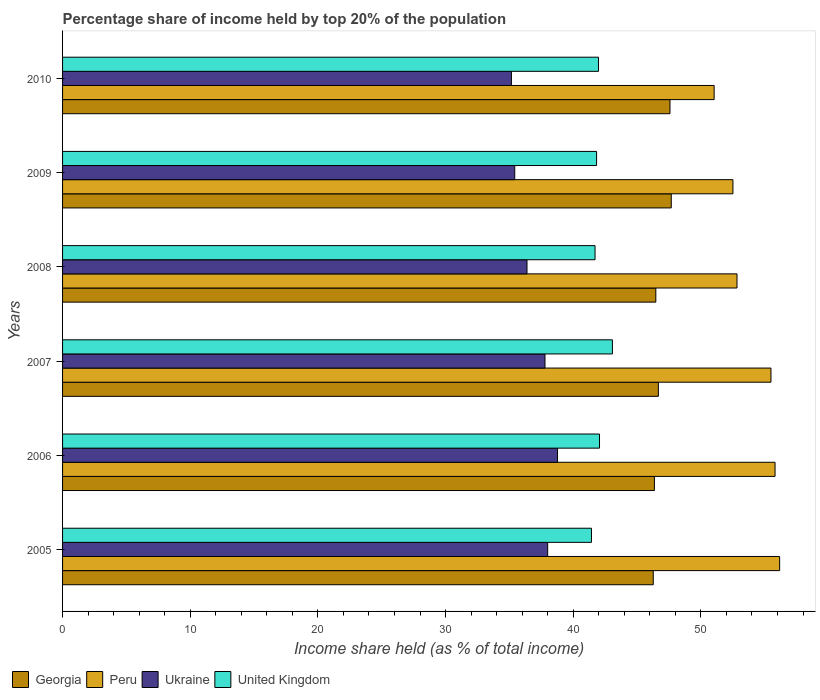How many different coloured bars are there?
Ensure brevity in your answer.  4. How many groups of bars are there?
Keep it short and to the point. 6. Are the number of bars per tick equal to the number of legend labels?
Your answer should be compact. Yes. Are the number of bars on each tick of the Y-axis equal?
Give a very brief answer. Yes. What is the label of the 1st group of bars from the top?
Offer a very short reply. 2010. In how many cases, is the number of bars for a given year not equal to the number of legend labels?
Give a very brief answer. 0. What is the percentage share of income held by top 20% of the population in Ukraine in 2010?
Your answer should be compact. 35.16. Across all years, what is the maximum percentage share of income held by top 20% of the population in Ukraine?
Ensure brevity in your answer.  38.77. Across all years, what is the minimum percentage share of income held by top 20% of the population in Georgia?
Give a very brief answer. 46.27. In which year was the percentage share of income held by top 20% of the population in United Kingdom maximum?
Ensure brevity in your answer.  2007. What is the total percentage share of income held by top 20% of the population in United Kingdom in the graph?
Make the answer very short. 252.08. What is the difference between the percentage share of income held by top 20% of the population in United Kingdom in 2006 and that in 2009?
Give a very brief answer. 0.23. What is the difference between the percentage share of income held by top 20% of the population in Ukraine in 2010 and the percentage share of income held by top 20% of the population in Peru in 2005?
Your answer should be very brief. -21.01. What is the average percentage share of income held by top 20% of the population in Georgia per year?
Provide a succinct answer. 46.84. In the year 2005, what is the difference between the percentage share of income held by top 20% of the population in Peru and percentage share of income held by top 20% of the population in Georgia?
Your answer should be very brief. 9.9. In how many years, is the percentage share of income held by top 20% of the population in Peru greater than 2 %?
Your answer should be compact. 6. What is the ratio of the percentage share of income held by top 20% of the population in Peru in 2007 to that in 2010?
Provide a short and direct response. 1.09. What is the difference between the highest and the second highest percentage share of income held by top 20% of the population in Peru?
Your response must be concise. 0.36. What is the difference between the highest and the lowest percentage share of income held by top 20% of the population in Ukraine?
Keep it short and to the point. 3.61. In how many years, is the percentage share of income held by top 20% of the population in United Kingdom greater than the average percentage share of income held by top 20% of the population in United Kingdom taken over all years?
Ensure brevity in your answer.  2. Is the sum of the percentage share of income held by top 20% of the population in Ukraine in 2006 and 2007 greater than the maximum percentage share of income held by top 20% of the population in Peru across all years?
Your answer should be very brief. Yes. What does the 3rd bar from the bottom in 2008 represents?
Keep it short and to the point. Ukraine. Is it the case that in every year, the sum of the percentage share of income held by top 20% of the population in Ukraine and percentage share of income held by top 20% of the population in Peru is greater than the percentage share of income held by top 20% of the population in United Kingdom?
Offer a terse response. Yes. How many years are there in the graph?
Provide a short and direct response. 6. Does the graph contain grids?
Your answer should be compact. No. Where does the legend appear in the graph?
Your answer should be very brief. Bottom left. How many legend labels are there?
Provide a short and direct response. 4. What is the title of the graph?
Your response must be concise. Percentage share of income held by top 20% of the population. What is the label or title of the X-axis?
Offer a terse response. Income share held (as % of total income). What is the label or title of the Y-axis?
Give a very brief answer. Years. What is the Income share held (as % of total income) in Georgia in 2005?
Keep it short and to the point. 46.27. What is the Income share held (as % of total income) in Peru in 2005?
Provide a succinct answer. 56.17. What is the Income share held (as % of total income) of Ukraine in 2005?
Offer a terse response. 38. What is the Income share held (as % of total income) of United Kingdom in 2005?
Your answer should be compact. 41.43. What is the Income share held (as % of total income) of Georgia in 2006?
Your response must be concise. 46.36. What is the Income share held (as % of total income) of Peru in 2006?
Provide a short and direct response. 55.81. What is the Income share held (as % of total income) in Ukraine in 2006?
Offer a terse response. 38.77. What is the Income share held (as % of total income) of United Kingdom in 2006?
Provide a short and direct response. 42.06. What is the Income share held (as % of total income) in Georgia in 2007?
Your response must be concise. 46.67. What is the Income share held (as % of total income) in Peru in 2007?
Give a very brief answer. 55.49. What is the Income share held (as % of total income) of Ukraine in 2007?
Your answer should be very brief. 37.79. What is the Income share held (as % of total income) in United Kingdom in 2007?
Provide a succinct answer. 43.07. What is the Income share held (as % of total income) in Georgia in 2008?
Make the answer very short. 46.47. What is the Income share held (as % of total income) in Peru in 2008?
Your answer should be very brief. 52.83. What is the Income share held (as % of total income) of Ukraine in 2008?
Your response must be concise. 36.38. What is the Income share held (as % of total income) of United Kingdom in 2008?
Offer a terse response. 41.71. What is the Income share held (as % of total income) in Georgia in 2009?
Offer a terse response. 47.68. What is the Income share held (as % of total income) of Peru in 2009?
Offer a terse response. 52.51. What is the Income share held (as % of total income) in Ukraine in 2009?
Keep it short and to the point. 35.42. What is the Income share held (as % of total income) of United Kingdom in 2009?
Your answer should be compact. 41.83. What is the Income share held (as % of total income) of Georgia in 2010?
Provide a succinct answer. 47.58. What is the Income share held (as % of total income) of Peru in 2010?
Your answer should be very brief. 51.04. What is the Income share held (as % of total income) of Ukraine in 2010?
Your answer should be very brief. 35.16. What is the Income share held (as % of total income) of United Kingdom in 2010?
Your response must be concise. 41.98. Across all years, what is the maximum Income share held (as % of total income) in Georgia?
Keep it short and to the point. 47.68. Across all years, what is the maximum Income share held (as % of total income) in Peru?
Keep it short and to the point. 56.17. Across all years, what is the maximum Income share held (as % of total income) of Ukraine?
Your answer should be compact. 38.77. Across all years, what is the maximum Income share held (as % of total income) of United Kingdom?
Make the answer very short. 43.07. Across all years, what is the minimum Income share held (as % of total income) in Georgia?
Your answer should be very brief. 46.27. Across all years, what is the minimum Income share held (as % of total income) in Peru?
Your answer should be very brief. 51.04. Across all years, what is the minimum Income share held (as % of total income) in Ukraine?
Give a very brief answer. 35.16. Across all years, what is the minimum Income share held (as % of total income) of United Kingdom?
Offer a very short reply. 41.43. What is the total Income share held (as % of total income) in Georgia in the graph?
Your answer should be very brief. 281.03. What is the total Income share held (as % of total income) in Peru in the graph?
Ensure brevity in your answer.  323.85. What is the total Income share held (as % of total income) in Ukraine in the graph?
Give a very brief answer. 221.52. What is the total Income share held (as % of total income) in United Kingdom in the graph?
Provide a short and direct response. 252.08. What is the difference between the Income share held (as % of total income) of Georgia in 2005 and that in 2006?
Offer a terse response. -0.09. What is the difference between the Income share held (as % of total income) in Peru in 2005 and that in 2006?
Offer a terse response. 0.36. What is the difference between the Income share held (as % of total income) in Ukraine in 2005 and that in 2006?
Offer a very short reply. -0.77. What is the difference between the Income share held (as % of total income) in United Kingdom in 2005 and that in 2006?
Make the answer very short. -0.63. What is the difference between the Income share held (as % of total income) of Peru in 2005 and that in 2007?
Offer a very short reply. 0.68. What is the difference between the Income share held (as % of total income) in Ukraine in 2005 and that in 2007?
Make the answer very short. 0.21. What is the difference between the Income share held (as % of total income) of United Kingdom in 2005 and that in 2007?
Your response must be concise. -1.64. What is the difference between the Income share held (as % of total income) in Georgia in 2005 and that in 2008?
Give a very brief answer. -0.2. What is the difference between the Income share held (as % of total income) in Peru in 2005 and that in 2008?
Ensure brevity in your answer.  3.34. What is the difference between the Income share held (as % of total income) in Ukraine in 2005 and that in 2008?
Keep it short and to the point. 1.62. What is the difference between the Income share held (as % of total income) in United Kingdom in 2005 and that in 2008?
Make the answer very short. -0.28. What is the difference between the Income share held (as % of total income) in Georgia in 2005 and that in 2009?
Your answer should be compact. -1.41. What is the difference between the Income share held (as % of total income) of Peru in 2005 and that in 2009?
Provide a short and direct response. 3.66. What is the difference between the Income share held (as % of total income) in Ukraine in 2005 and that in 2009?
Give a very brief answer. 2.58. What is the difference between the Income share held (as % of total income) in Georgia in 2005 and that in 2010?
Ensure brevity in your answer.  -1.31. What is the difference between the Income share held (as % of total income) of Peru in 2005 and that in 2010?
Keep it short and to the point. 5.13. What is the difference between the Income share held (as % of total income) of Ukraine in 2005 and that in 2010?
Your response must be concise. 2.84. What is the difference between the Income share held (as % of total income) of United Kingdom in 2005 and that in 2010?
Provide a short and direct response. -0.55. What is the difference between the Income share held (as % of total income) of Georgia in 2006 and that in 2007?
Your answer should be compact. -0.31. What is the difference between the Income share held (as % of total income) of Peru in 2006 and that in 2007?
Keep it short and to the point. 0.32. What is the difference between the Income share held (as % of total income) in Ukraine in 2006 and that in 2007?
Give a very brief answer. 0.98. What is the difference between the Income share held (as % of total income) of United Kingdom in 2006 and that in 2007?
Your answer should be compact. -1.01. What is the difference between the Income share held (as % of total income) in Georgia in 2006 and that in 2008?
Provide a succinct answer. -0.11. What is the difference between the Income share held (as % of total income) in Peru in 2006 and that in 2008?
Your answer should be compact. 2.98. What is the difference between the Income share held (as % of total income) in Ukraine in 2006 and that in 2008?
Provide a succinct answer. 2.39. What is the difference between the Income share held (as % of total income) of United Kingdom in 2006 and that in 2008?
Give a very brief answer. 0.35. What is the difference between the Income share held (as % of total income) in Georgia in 2006 and that in 2009?
Make the answer very short. -1.32. What is the difference between the Income share held (as % of total income) in Ukraine in 2006 and that in 2009?
Make the answer very short. 3.35. What is the difference between the Income share held (as % of total income) in United Kingdom in 2006 and that in 2009?
Give a very brief answer. 0.23. What is the difference between the Income share held (as % of total income) of Georgia in 2006 and that in 2010?
Provide a short and direct response. -1.22. What is the difference between the Income share held (as % of total income) of Peru in 2006 and that in 2010?
Your response must be concise. 4.77. What is the difference between the Income share held (as % of total income) in Ukraine in 2006 and that in 2010?
Your answer should be compact. 3.61. What is the difference between the Income share held (as % of total income) in Peru in 2007 and that in 2008?
Give a very brief answer. 2.66. What is the difference between the Income share held (as % of total income) in Ukraine in 2007 and that in 2008?
Give a very brief answer. 1.41. What is the difference between the Income share held (as % of total income) in United Kingdom in 2007 and that in 2008?
Make the answer very short. 1.36. What is the difference between the Income share held (as % of total income) in Georgia in 2007 and that in 2009?
Provide a succinct answer. -1.01. What is the difference between the Income share held (as % of total income) in Peru in 2007 and that in 2009?
Your answer should be very brief. 2.98. What is the difference between the Income share held (as % of total income) of Ukraine in 2007 and that in 2009?
Your answer should be very brief. 2.37. What is the difference between the Income share held (as % of total income) in United Kingdom in 2007 and that in 2009?
Your response must be concise. 1.24. What is the difference between the Income share held (as % of total income) of Georgia in 2007 and that in 2010?
Your response must be concise. -0.91. What is the difference between the Income share held (as % of total income) of Peru in 2007 and that in 2010?
Give a very brief answer. 4.45. What is the difference between the Income share held (as % of total income) in Ukraine in 2007 and that in 2010?
Your answer should be very brief. 2.63. What is the difference between the Income share held (as % of total income) of United Kingdom in 2007 and that in 2010?
Offer a very short reply. 1.09. What is the difference between the Income share held (as % of total income) of Georgia in 2008 and that in 2009?
Your answer should be compact. -1.21. What is the difference between the Income share held (as % of total income) in Peru in 2008 and that in 2009?
Your answer should be very brief. 0.32. What is the difference between the Income share held (as % of total income) in United Kingdom in 2008 and that in 2009?
Your answer should be compact. -0.12. What is the difference between the Income share held (as % of total income) in Georgia in 2008 and that in 2010?
Provide a short and direct response. -1.11. What is the difference between the Income share held (as % of total income) of Peru in 2008 and that in 2010?
Offer a very short reply. 1.79. What is the difference between the Income share held (as % of total income) of Ukraine in 2008 and that in 2010?
Provide a succinct answer. 1.22. What is the difference between the Income share held (as % of total income) of United Kingdom in 2008 and that in 2010?
Ensure brevity in your answer.  -0.27. What is the difference between the Income share held (as % of total income) in Peru in 2009 and that in 2010?
Keep it short and to the point. 1.47. What is the difference between the Income share held (as % of total income) in Ukraine in 2009 and that in 2010?
Your answer should be compact. 0.26. What is the difference between the Income share held (as % of total income) in Georgia in 2005 and the Income share held (as % of total income) in Peru in 2006?
Your response must be concise. -9.54. What is the difference between the Income share held (as % of total income) in Georgia in 2005 and the Income share held (as % of total income) in Ukraine in 2006?
Make the answer very short. 7.5. What is the difference between the Income share held (as % of total income) of Georgia in 2005 and the Income share held (as % of total income) of United Kingdom in 2006?
Ensure brevity in your answer.  4.21. What is the difference between the Income share held (as % of total income) in Peru in 2005 and the Income share held (as % of total income) in United Kingdom in 2006?
Give a very brief answer. 14.11. What is the difference between the Income share held (as % of total income) in Ukraine in 2005 and the Income share held (as % of total income) in United Kingdom in 2006?
Keep it short and to the point. -4.06. What is the difference between the Income share held (as % of total income) in Georgia in 2005 and the Income share held (as % of total income) in Peru in 2007?
Provide a short and direct response. -9.22. What is the difference between the Income share held (as % of total income) in Georgia in 2005 and the Income share held (as % of total income) in Ukraine in 2007?
Make the answer very short. 8.48. What is the difference between the Income share held (as % of total income) of Peru in 2005 and the Income share held (as % of total income) of Ukraine in 2007?
Offer a very short reply. 18.38. What is the difference between the Income share held (as % of total income) in Peru in 2005 and the Income share held (as % of total income) in United Kingdom in 2007?
Offer a very short reply. 13.1. What is the difference between the Income share held (as % of total income) in Ukraine in 2005 and the Income share held (as % of total income) in United Kingdom in 2007?
Offer a very short reply. -5.07. What is the difference between the Income share held (as % of total income) of Georgia in 2005 and the Income share held (as % of total income) of Peru in 2008?
Your answer should be very brief. -6.56. What is the difference between the Income share held (as % of total income) of Georgia in 2005 and the Income share held (as % of total income) of Ukraine in 2008?
Ensure brevity in your answer.  9.89. What is the difference between the Income share held (as % of total income) in Georgia in 2005 and the Income share held (as % of total income) in United Kingdom in 2008?
Your response must be concise. 4.56. What is the difference between the Income share held (as % of total income) in Peru in 2005 and the Income share held (as % of total income) in Ukraine in 2008?
Offer a very short reply. 19.79. What is the difference between the Income share held (as % of total income) of Peru in 2005 and the Income share held (as % of total income) of United Kingdom in 2008?
Provide a succinct answer. 14.46. What is the difference between the Income share held (as % of total income) in Ukraine in 2005 and the Income share held (as % of total income) in United Kingdom in 2008?
Give a very brief answer. -3.71. What is the difference between the Income share held (as % of total income) in Georgia in 2005 and the Income share held (as % of total income) in Peru in 2009?
Offer a terse response. -6.24. What is the difference between the Income share held (as % of total income) of Georgia in 2005 and the Income share held (as % of total income) of Ukraine in 2009?
Your response must be concise. 10.85. What is the difference between the Income share held (as % of total income) in Georgia in 2005 and the Income share held (as % of total income) in United Kingdom in 2009?
Your answer should be very brief. 4.44. What is the difference between the Income share held (as % of total income) in Peru in 2005 and the Income share held (as % of total income) in Ukraine in 2009?
Your answer should be very brief. 20.75. What is the difference between the Income share held (as % of total income) in Peru in 2005 and the Income share held (as % of total income) in United Kingdom in 2009?
Your response must be concise. 14.34. What is the difference between the Income share held (as % of total income) of Ukraine in 2005 and the Income share held (as % of total income) of United Kingdom in 2009?
Offer a very short reply. -3.83. What is the difference between the Income share held (as % of total income) in Georgia in 2005 and the Income share held (as % of total income) in Peru in 2010?
Offer a very short reply. -4.77. What is the difference between the Income share held (as % of total income) of Georgia in 2005 and the Income share held (as % of total income) of Ukraine in 2010?
Offer a very short reply. 11.11. What is the difference between the Income share held (as % of total income) in Georgia in 2005 and the Income share held (as % of total income) in United Kingdom in 2010?
Your response must be concise. 4.29. What is the difference between the Income share held (as % of total income) in Peru in 2005 and the Income share held (as % of total income) in Ukraine in 2010?
Provide a succinct answer. 21.01. What is the difference between the Income share held (as % of total income) of Peru in 2005 and the Income share held (as % of total income) of United Kingdom in 2010?
Provide a short and direct response. 14.19. What is the difference between the Income share held (as % of total income) of Ukraine in 2005 and the Income share held (as % of total income) of United Kingdom in 2010?
Offer a very short reply. -3.98. What is the difference between the Income share held (as % of total income) in Georgia in 2006 and the Income share held (as % of total income) in Peru in 2007?
Give a very brief answer. -9.13. What is the difference between the Income share held (as % of total income) of Georgia in 2006 and the Income share held (as % of total income) of Ukraine in 2007?
Offer a very short reply. 8.57. What is the difference between the Income share held (as % of total income) of Georgia in 2006 and the Income share held (as % of total income) of United Kingdom in 2007?
Make the answer very short. 3.29. What is the difference between the Income share held (as % of total income) of Peru in 2006 and the Income share held (as % of total income) of Ukraine in 2007?
Keep it short and to the point. 18.02. What is the difference between the Income share held (as % of total income) of Peru in 2006 and the Income share held (as % of total income) of United Kingdom in 2007?
Provide a succinct answer. 12.74. What is the difference between the Income share held (as % of total income) in Georgia in 2006 and the Income share held (as % of total income) in Peru in 2008?
Give a very brief answer. -6.47. What is the difference between the Income share held (as % of total income) of Georgia in 2006 and the Income share held (as % of total income) of Ukraine in 2008?
Ensure brevity in your answer.  9.98. What is the difference between the Income share held (as % of total income) of Georgia in 2006 and the Income share held (as % of total income) of United Kingdom in 2008?
Offer a terse response. 4.65. What is the difference between the Income share held (as % of total income) of Peru in 2006 and the Income share held (as % of total income) of Ukraine in 2008?
Keep it short and to the point. 19.43. What is the difference between the Income share held (as % of total income) of Ukraine in 2006 and the Income share held (as % of total income) of United Kingdom in 2008?
Your response must be concise. -2.94. What is the difference between the Income share held (as % of total income) of Georgia in 2006 and the Income share held (as % of total income) of Peru in 2009?
Provide a short and direct response. -6.15. What is the difference between the Income share held (as % of total income) of Georgia in 2006 and the Income share held (as % of total income) of Ukraine in 2009?
Offer a terse response. 10.94. What is the difference between the Income share held (as % of total income) in Georgia in 2006 and the Income share held (as % of total income) in United Kingdom in 2009?
Provide a succinct answer. 4.53. What is the difference between the Income share held (as % of total income) in Peru in 2006 and the Income share held (as % of total income) in Ukraine in 2009?
Your answer should be compact. 20.39. What is the difference between the Income share held (as % of total income) in Peru in 2006 and the Income share held (as % of total income) in United Kingdom in 2009?
Keep it short and to the point. 13.98. What is the difference between the Income share held (as % of total income) of Ukraine in 2006 and the Income share held (as % of total income) of United Kingdom in 2009?
Your answer should be compact. -3.06. What is the difference between the Income share held (as % of total income) in Georgia in 2006 and the Income share held (as % of total income) in Peru in 2010?
Provide a short and direct response. -4.68. What is the difference between the Income share held (as % of total income) of Georgia in 2006 and the Income share held (as % of total income) of United Kingdom in 2010?
Provide a succinct answer. 4.38. What is the difference between the Income share held (as % of total income) in Peru in 2006 and the Income share held (as % of total income) in Ukraine in 2010?
Your response must be concise. 20.65. What is the difference between the Income share held (as % of total income) in Peru in 2006 and the Income share held (as % of total income) in United Kingdom in 2010?
Offer a very short reply. 13.83. What is the difference between the Income share held (as % of total income) in Ukraine in 2006 and the Income share held (as % of total income) in United Kingdom in 2010?
Your response must be concise. -3.21. What is the difference between the Income share held (as % of total income) of Georgia in 2007 and the Income share held (as % of total income) of Peru in 2008?
Keep it short and to the point. -6.16. What is the difference between the Income share held (as % of total income) in Georgia in 2007 and the Income share held (as % of total income) in Ukraine in 2008?
Ensure brevity in your answer.  10.29. What is the difference between the Income share held (as % of total income) in Georgia in 2007 and the Income share held (as % of total income) in United Kingdom in 2008?
Make the answer very short. 4.96. What is the difference between the Income share held (as % of total income) in Peru in 2007 and the Income share held (as % of total income) in Ukraine in 2008?
Keep it short and to the point. 19.11. What is the difference between the Income share held (as % of total income) in Peru in 2007 and the Income share held (as % of total income) in United Kingdom in 2008?
Provide a short and direct response. 13.78. What is the difference between the Income share held (as % of total income) in Ukraine in 2007 and the Income share held (as % of total income) in United Kingdom in 2008?
Provide a succinct answer. -3.92. What is the difference between the Income share held (as % of total income) in Georgia in 2007 and the Income share held (as % of total income) in Peru in 2009?
Offer a terse response. -5.84. What is the difference between the Income share held (as % of total income) in Georgia in 2007 and the Income share held (as % of total income) in Ukraine in 2009?
Give a very brief answer. 11.25. What is the difference between the Income share held (as % of total income) of Georgia in 2007 and the Income share held (as % of total income) of United Kingdom in 2009?
Keep it short and to the point. 4.84. What is the difference between the Income share held (as % of total income) of Peru in 2007 and the Income share held (as % of total income) of Ukraine in 2009?
Offer a terse response. 20.07. What is the difference between the Income share held (as % of total income) of Peru in 2007 and the Income share held (as % of total income) of United Kingdom in 2009?
Keep it short and to the point. 13.66. What is the difference between the Income share held (as % of total income) of Ukraine in 2007 and the Income share held (as % of total income) of United Kingdom in 2009?
Your answer should be compact. -4.04. What is the difference between the Income share held (as % of total income) in Georgia in 2007 and the Income share held (as % of total income) in Peru in 2010?
Your response must be concise. -4.37. What is the difference between the Income share held (as % of total income) in Georgia in 2007 and the Income share held (as % of total income) in Ukraine in 2010?
Offer a terse response. 11.51. What is the difference between the Income share held (as % of total income) of Georgia in 2007 and the Income share held (as % of total income) of United Kingdom in 2010?
Offer a very short reply. 4.69. What is the difference between the Income share held (as % of total income) in Peru in 2007 and the Income share held (as % of total income) in Ukraine in 2010?
Your answer should be compact. 20.33. What is the difference between the Income share held (as % of total income) in Peru in 2007 and the Income share held (as % of total income) in United Kingdom in 2010?
Offer a terse response. 13.51. What is the difference between the Income share held (as % of total income) of Ukraine in 2007 and the Income share held (as % of total income) of United Kingdom in 2010?
Give a very brief answer. -4.19. What is the difference between the Income share held (as % of total income) in Georgia in 2008 and the Income share held (as % of total income) in Peru in 2009?
Offer a very short reply. -6.04. What is the difference between the Income share held (as % of total income) in Georgia in 2008 and the Income share held (as % of total income) in Ukraine in 2009?
Make the answer very short. 11.05. What is the difference between the Income share held (as % of total income) in Georgia in 2008 and the Income share held (as % of total income) in United Kingdom in 2009?
Offer a very short reply. 4.64. What is the difference between the Income share held (as % of total income) in Peru in 2008 and the Income share held (as % of total income) in Ukraine in 2009?
Keep it short and to the point. 17.41. What is the difference between the Income share held (as % of total income) in Ukraine in 2008 and the Income share held (as % of total income) in United Kingdom in 2009?
Offer a very short reply. -5.45. What is the difference between the Income share held (as % of total income) in Georgia in 2008 and the Income share held (as % of total income) in Peru in 2010?
Give a very brief answer. -4.57. What is the difference between the Income share held (as % of total income) of Georgia in 2008 and the Income share held (as % of total income) of Ukraine in 2010?
Offer a terse response. 11.31. What is the difference between the Income share held (as % of total income) in Georgia in 2008 and the Income share held (as % of total income) in United Kingdom in 2010?
Your answer should be compact. 4.49. What is the difference between the Income share held (as % of total income) of Peru in 2008 and the Income share held (as % of total income) of Ukraine in 2010?
Give a very brief answer. 17.67. What is the difference between the Income share held (as % of total income) of Peru in 2008 and the Income share held (as % of total income) of United Kingdom in 2010?
Ensure brevity in your answer.  10.85. What is the difference between the Income share held (as % of total income) of Georgia in 2009 and the Income share held (as % of total income) of Peru in 2010?
Keep it short and to the point. -3.36. What is the difference between the Income share held (as % of total income) in Georgia in 2009 and the Income share held (as % of total income) in Ukraine in 2010?
Provide a short and direct response. 12.52. What is the difference between the Income share held (as % of total income) of Peru in 2009 and the Income share held (as % of total income) of Ukraine in 2010?
Provide a short and direct response. 17.35. What is the difference between the Income share held (as % of total income) in Peru in 2009 and the Income share held (as % of total income) in United Kingdom in 2010?
Offer a terse response. 10.53. What is the difference between the Income share held (as % of total income) of Ukraine in 2009 and the Income share held (as % of total income) of United Kingdom in 2010?
Offer a terse response. -6.56. What is the average Income share held (as % of total income) of Georgia per year?
Your answer should be very brief. 46.84. What is the average Income share held (as % of total income) in Peru per year?
Provide a short and direct response. 53.98. What is the average Income share held (as % of total income) in Ukraine per year?
Your answer should be very brief. 36.92. What is the average Income share held (as % of total income) in United Kingdom per year?
Give a very brief answer. 42.01. In the year 2005, what is the difference between the Income share held (as % of total income) of Georgia and Income share held (as % of total income) of Ukraine?
Give a very brief answer. 8.27. In the year 2005, what is the difference between the Income share held (as % of total income) in Georgia and Income share held (as % of total income) in United Kingdom?
Ensure brevity in your answer.  4.84. In the year 2005, what is the difference between the Income share held (as % of total income) of Peru and Income share held (as % of total income) of Ukraine?
Offer a very short reply. 18.17. In the year 2005, what is the difference between the Income share held (as % of total income) of Peru and Income share held (as % of total income) of United Kingdom?
Make the answer very short. 14.74. In the year 2005, what is the difference between the Income share held (as % of total income) of Ukraine and Income share held (as % of total income) of United Kingdom?
Provide a short and direct response. -3.43. In the year 2006, what is the difference between the Income share held (as % of total income) of Georgia and Income share held (as % of total income) of Peru?
Your answer should be very brief. -9.45. In the year 2006, what is the difference between the Income share held (as % of total income) of Georgia and Income share held (as % of total income) of Ukraine?
Provide a short and direct response. 7.59. In the year 2006, what is the difference between the Income share held (as % of total income) of Georgia and Income share held (as % of total income) of United Kingdom?
Give a very brief answer. 4.3. In the year 2006, what is the difference between the Income share held (as % of total income) of Peru and Income share held (as % of total income) of Ukraine?
Your answer should be compact. 17.04. In the year 2006, what is the difference between the Income share held (as % of total income) in Peru and Income share held (as % of total income) in United Kingdom?
Offer a very short reply. 13.75. In the year 2006, what is the difference between the Income share held (as % of total income) of Ukraine and Income share held (as % of total income) of United Kingdom?
Your answer should be very brief. -3.29. In the year 2007, what is the difference between the Income share held (as % of total income) in Georgia and Income share held (as % of total income) in Peru?
Offer a terse response. -8.82. In the year 2007, what is the difference between the Income share held (as % of total income) in Georgia and Income share held (as % of total income) in Ukraine?
Ensure brevity in your answer.  8.88. In the year 2007, what is the difference between the Income share held (as % of total income) in Georgia and Income share held (as % of total income) in United Kingdom?
Provide a succinct answer. 3.6. In the year 2007, what is the difference between the Income share held (as % of total income) in Peru and Income share held (as % of total income) in United Kingdom?
Your response must be concise. 12.42. In the year 2007, what is the difference between the Income share held (as % of total income) of Ukraine and Income share held (as % of total income) of United Kingdom?
Offer a terse response. -5.28. In the year 2008, what is the difference between the Income share held (as % of total income) in Georgia and Income share held (as % of total income) in Peru?
Provide a short and direct response. -6.36. In the year 2008, what is the difference between the Income share held (as % of total income) in Georgia and Income share held (as % of total income) in Ukraine?
Provide a succinct answer. 10.09. In the year 2008, what is the difference between the Income share held (as % of total income) in Georgia and Income share held (as % of total income) in United Kingdom?
Give a very brief answer. 4.76. In the year 2008, what is the difference between the Income share held (as % of total income) in Peru and Income share held (as % of total income) in Ukraine?
Provide a succinct answer. 16.45. In the year 2008, what is the difference between the Income share held (as % of total income) in Peru and Income share held (as % of total income) in United Kingdom?
Provide a succinct answer. 11.12. In the year 2008, what is the difference between the Income share held (as % of total income) in Ukraine and Income share held (as % of total income) in United Kingdom?
Provide a short and direct response. -5.33. In the year 2009, what is the difference between the Income share held (as % of total income) of Georgia and Income share held (as % of total income) of Peru?
Your answer should be very brief. -4.83. In the year 2009, what is the difference between the Income share held (as % of total income) in Georgia and Income share held (as % of total income) in Ukraine?
Your answer should be very brief. 12.26. In the year 2009, what is the difference between the Income share held (as % of total income) of Georgia and Income share held (as % of total income) of United Kingdom?
Offer a terse response. 5.85. In the year 2009, what is the difference between the Income share held (as % of total income) of Peru and Income share held (as % of total income) of Ukraine?
Ensure brevity in your answer.  17.09. In the year 2009, what is the difference between the Income share held (as % of total income) of Peru and Income share held (as % of total income) of United Kingdom?
Your answer should be very brief. 10.68. In the year 2009, what is the difference between the Income share held (as % of total income) of Ukraine and Income share held (as % of total income) of United Kingdom?
Provide a succinct answer. -6.41. In the year 2010, what is the difference between the Income share held (as % of total income) of Georgia and Income share held (as % of total income) of Peru?
Provide a succinct answer. -3.46. In the year 2010, what is the difference between the Income share held (as % of total income) of Georgia and Income share held (as % of total income) of Ukraine?
Offer a terse response. 12.42. In the year 2010, what is the difference between the Income share held (as % of total income) of Georgia and Income share held (as % of total income) of United Kingdom?
Your response must be concise. 5.6. In the year 2010, what is the difference between the Income share held (as % of total income) of Peru and Income share held (as % of total income) of Ukraine?
Offer a very short reply. 15.88. In the year 2010, what is the difference between the Income share held (as % of total income) in Peru and Income share held (as % of total income) in United Kingdom?
Your answer should be compact. 9.06. In the year 2010, what is the difference between the Income share held (as % of total income) of Ukraine and Income share held (as % of total income) of United Kingdom?
Provide a succinct answer. -6.82. What is the ratio of the Income share held (as % of total income) of Georgia in 2005 to that in 2006?
Offer a very short reply. 1. What is the ratio of the Income share held (as % of total income) of Peru in 2005 to that in 2006?
Keep it short and to the point. 1.01. What is the ratio of the Income share held (as % of total income) of Ukraine in 2005 to that in 2006?
Your response must be concise. 0.98. What is the ratio of the Income share held (as % of total income) in Georgia in 2005 to that in 2007?
Your answer should be compact. 0.99. What is the ratio of the Income share held (as % of total income) of Peru in 2005 to that in 2007?
Offer a very short reply. 1.01. What is the ratio of the Income share held (as % of total income) of Ukraine in 2005 to that in 2007?
Ensure brevity in your answer.  1.01. What is the ratio of the Income share held (as % of total income) in United Kingdom in 2005 to that in 2007?
Provide a short and direct response. 0.96. What is the ratio of the Income share held (as % of total income) in Georgia in 2005 to that in 2008?
Provide a succinct answer. 1. What is the ratio of the Income share held (as % of total income) in Peru in 2005 to that in 2008?
Ensure brevity in your answer.  1.06. What is the ratio of the Income share held (as % of total income) in Ukraine in 2005 to that in 2008?
Provide a succinct answer. 1.04. What is the ratio of the Income share held (as % of total income) in United Kingdom in 2005 to that in 2008?
Provide a succinct answer. 0.99. What is the ratio of the Income share held (as % of total income) in Georgia in 2005 to that in 2009?
Ensure brevity in your answer.  0.97. What is the ratio of the Income share held (as % of total income) of Peru in 2005 to that in 2009?
Make the answer very short. 1.07. What is the ratio of the Income share held (as % of total income) in Ukraine in 2005 to that in 2009?
Keep it short and to the point. 1.07. What is the ratio of the Income share held (as % of total income) of Georgia in 2005 to that in 2010?
Make the answer very short. 0.97. What is the ratio of the Income share held (as % of total income) of Peru in 2005 to that in 2010?
Offer a very short reply. 1.1. What is the ratio of the Income share held (as % of total income) of Ukraine in 2005 to that in 2010?
Provide a short and direct response. 1.08. What is the ratio of the Income share held (as % of total income) in United Kingdom in 2005 to that in 2010?
Give a very brief answer. 0.99. What is the ratio of the Income share held (as % of total income) in Georgia in 2006 to that in 2007?
Offer a very short reply. 0.99. What is the ratio of the Income share held (as % of total income) of Ukraine in 2006 to that in 2007?
Your answer should be very brief. 1.03. What is the ratio of the Income share held (as % of total income) of United Kingdom in 2006 to that in 2007?
Your answer should be very brief. 0.98. What is the ratio of the Income share held (as % of total income) in Peru in 2006 to that in 2008?
Your response must be concise. 1.06. What is the ratio of the Income share held (as % of total income) in Ukraine in 2006 to that in 2008?
Offer a terse response. 1.07. What is the ratio of the Income share held (as % of total income) of United Kingdom in 2006 to that in 2008?
Your answer should be very brief. 1.01. What is the ratio of the Income share held (as % of total income) in Georgia in 2006 to that in 2009?
Give a very brief answer. 0.97. What is the ratio of the Income share held (as % of total income) of Peru in 2006 to that in 2009?
Make the answer very short. 1.06. What is the ratio of the Income share held (as % of total income) of Ukraine in 2006 to that in 2009?
Give a very brief answer. 1.09. What is the ratio of the Income share held (as % of total income) of Georgia in 2006 to that in 2010?
Make the answer very short. 0.97. What is the ratio of the Income share held (as % of total income) of Peru in 2006 to that in 2010?
Keep it short and to the point. 1.09. What is the ratio of the Income share held (as % of total income) of Ukraine in 2006 to that in 2010?
Provide a succinct answer. 1.1. What is the ratio of the Income share held (as % of total income) in Georgia in 2007 to that in 2008?
Keep it short and to the point. 1. What is the ratio of the Income share held (as % of total income) of Peru in 2007 to that in 2008?
Make the answer very short. 1.05. What is the ratio of the Income share held (as % of total income) of Ukraine in 2007 to that in 2008?
Offer a very short reply. 1.04. What is the ratio of the Income share held (as % of total income) of United Kingdom in 2007 to that in 2008?
Your answer should be very brief. 1.03. What is the ratio of the Income share held (as % of total income) in Georgia in 2007 to that in 2009?
Your response must be concise. 0.98. What is the ratio of the Income share held (as % of total income) in Peru in 2007 to that in 2009?
Your answer should be compact. 1.06. What is the ratio of the Income share held (as % of total income) of Ukraine in 2007 to that in 2009?
Make the answer very short. 1.07. What is the ratio of the Income share held (as % of total income) of United Kingdom in 2007 to that in 2009?
Your answer should be compact. 1.03. What is the ratio of the Income share held (as % of total income) of Georgia in 2007 to that in 2010?
Your answer should be very brief. 0.98. What is the ratio of the Income share held (as % of total income) in Peru in 2007 to that in 2010?
Ensure brevity in your answer.  1.09. What is the ratio of the Income share held (as % of total income) in Ukraine in 2007 to that in 2010?
Make the answer very short. 1.07. What is the ratio of the Income share held (as % of total income) in Georgia in 2008 to that in 2009?
Your answer should be compact. 0.97. What is the ratio of the Income share held (as % of total income) in Ukraine in 2008 to that in 2009?
Provide a short and direct response. 1.03. What is the ratio of the Income share held (as % of total income) in United Kingdom in 2008 to that in 2009?
Give a very brief answer. 1. What is the ratio of the Income share held (as % of total income) in Georgia in 2008 to that in 2010?
Offer a terse response. 0.98. What is the ratio of the Income share held (as % of total income) in Peru in 2008 to that in 2010?
Make the answer very short. 1.04. What is the ratio of the Income share held (as % of total income) of Ukraine in 2008 to that in 2010?
Your response must be concise. 1.03. What is the ratio of the Income share held (as % of total income) of Georgia in 2009 to that in 2010?
Provide a short and direct response. 1. What is the ratio of the Income share held (as % of total income) in Peru in 2009 to that in 2010?
Provide a short and direct response. 1.03. What is the ratio of the Income share held (as % of total income) of Ukraine in 2009 to that in 2010?
Ensure brevity in your answer.  1.01. What is the ratio of the Income share held (as % of total income) of United Kingdom in 2009 to that in 2010?
Your answer should be very brief. 1. What is the difference between the highest and the second highest Income share held (as % of total income) in Peru?
Provide a short and direct response. 0.36. What is the difference between the highest and the second highest Income share held (as % of total income) of Ukraine?
Make the answer very short. 0.77. What is the difference between the highest and the second highest Income share held (as % of total income) of United Kingdom?
Your response must be concise. 1.01. What is the difference between the highest and the lowest Income share held (as % of total income) of Georgia?
Offer a terse response. 1.41. What is the difference between the highest and the lowest Income share held (as % of total income) of Peru?
Ensure brevity in your answer.  5.13. What is the difference between the highest and the lowest Income share held (as % of total income) of Ukraine?
Ensure brevity in your answer.  3.61. What is the difference between the highest and the lowest Income share held (as % of total income) in United Kingdom?
Your answer should be very brief. 1.64. 